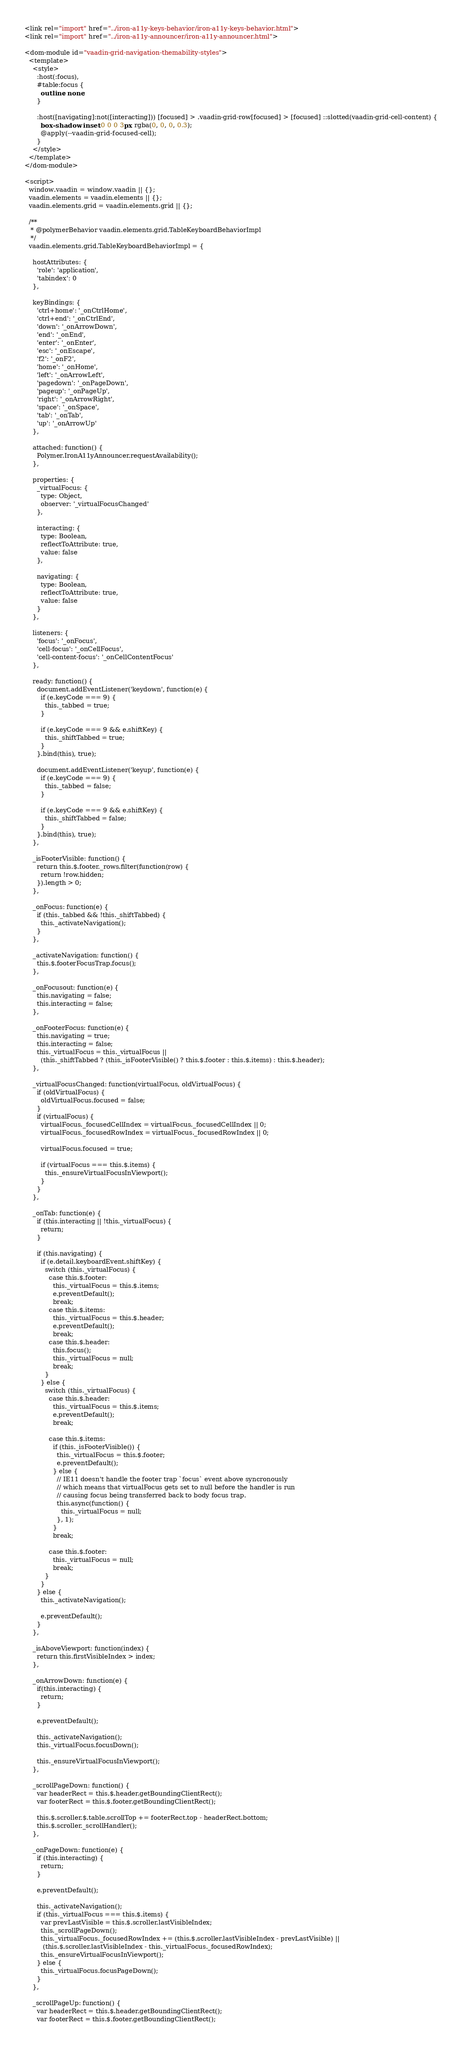<code> <loc_0><loc_0><loc_500><loc_500><_HTML_><link rel="import" href="../iron-a11y-keys-behavior/iron-a11y-keys-behavior.html">
<link rel="import" href="../iron-a11y-announcer/iron-a11y-announcer.html">

<dom-module id="vaadin-grid-navigation-themability-styles">
  <template>
    <style>
      :host(:focus),
      #table:focus {
        outline: none;
      }

      :host([navigating]:not([interacting])) [focused] > .vaadin-grid-row[focused] > [focused] ::slotted(vaadin-grid-cell-content) {
        box-shadow: inset 0 0 0 3px rgba(0, 0, 0, 0.3);
        @apply(--vaadin-grid-focused-cell);
      }
    </style>
  </template>
</dom-module>

<script>
  window.vaadin = window.vaadin || {};
  vaadin.elements = vaadin.elements || {};
  vaadin.elements.grid = vaadin.elements.grid || {};

  /**
   * @polymerBehavior vaadin.elements.grid.TableKeyboardBehaviorImpl
   */
  vaadin.elements.grid.TableKeyboardBehaviorImpl = {

    hostAttributes: {
      'role': 'application',
      'tabindex': 0
    },

    keyBindings: {
      'ctrl+home': '_onCtrlHome',
      'ctrl+end': '_onCtrlEnd',
      'down': '_onArrowDown',
      'end': '_onEnd',
      'enter': '_onEnter',
      'esc': '_onEscape',
      'f2': '_onF2',
      'home': '_onHome',
      'left': '_onArrowLeft',
      'pagedown': '_onPageDown',
      'pageup': '_onPageUp',
      'right': '_onArrowRight',
      'space': '_onSpace',
      'tab': '_onTab',
      'up': '_onArrowUp'
    },

    attached: function() {
      Polymer.IronA11yAnnouncer.requestAvailability();
    },

    properties: {
      _virtualFocus: {
        type: Object,
        observer: '_virtualFocusChanged'
      },

      interacting: {
        type: Boolean,
        reflectToAttribute: true,
        value: false
      },

      navigating: {
        type: Boolean,
        reflectToAttribute: true,
        value: false
      }
    },

    listeners: {
      'focus': '_onFocus',
      'cell-focus': '_onCellFocus',
      'cell-content-focus': '_onCellContentFocus'
    },

    ready: function() {
      document.addEventListener('keydown', function(e) {
        if (e.keyCode === 9) {
          this._tabbed = true;
        }

        if (e.keyCode === 9 && e.shiftKey) {
          this._shiftTabbed = true;
        }
      }.bind(this), true);

      document.addEventListener('keyup', function(e) {
        if (e.keyCode === 9) {
          this._tabbed = false;
        }

        if (e.keyCode === 9 && e.shiftKey) {
          this._shiftTabbed = false;
        }
      }.bind(this), true);
    },

    _isFooterVisible: function() {
      return this.$.footer._rows.filter(function(row) {
        return !row.hidden;
      }).length > 0;
    },

    _onFocus: function(e) {
      if (this._tabbed && !this._shiftTabbed) {
        this._activateNavigation();
      }
    },

    _activateNavigation: function() {
      this.$.footerFocusTrap.focus();
    },

    _onFocusout: function(e) {
      this.navigating = false;
      this.interacting = false;
    },

    _onFooterFocus: function(e) {
      this.navigating = true;
      this.interacting = false;
      this._virtualFocus = this._virtualFocus ||
        (this._shiftTabbed ? (this._isFooterVisible() ? this.$.footer : this.$.items) : this.$.header);
    },

    _virtualFocusChanged: function(virtualFocus, oldVirtualFocus) {
      if (oldVirtualFocus) {
        oldVirtualFocus.focused = false;
      }
      if (virtualFocus) {
        virtualFocus._focusedCellIndex = virtualFocus._focusedCellIndex || 0;
        virtualFocus._focusedRowIndex = virtualFocus._focusedRowIndex || 0;

        virtualFocus.focused = true;

        if (virtualFocus === this.$.items) {
          this._ensureVirtualFocusInViewport();
        }
      }
    },

    _onTab: function(e) {
      if (this.interacting || !this._virtualFocus) {
        return;
      }

      if (this.navigating) {
        if (e.detail.keyboardEvent.shiftKey) {
          switch (this._virtualFocus) {
            case this.$.footer:
              this._virtualFocus = this.$.items;
              e.preventDefault();
              break;
            case this.$.items:
              this._virtualFocus = this.$.header;
              e.preventDefault();
              break;
            case this.$.header:
              this.focus();
              this._virtualFocus = null;
              break;
          }
        } else {
          switch (this._virtualFocus) {
            case this.$.header:
              this._virtualFocus = this.$.items;
              e.preventDefault();
              break;

            case this.$.items:
              if (this._isFooterVisible()) {
                this._virtualFocus = this.$.footer;
                e.preventDefault();
              } else {
                // IE11 doesn't handle the footer trap `focus` event above syncronously
                // which means that virtualFocus gets set to null before the handler is run
                // causing focus being transferred back to body focus trap.
                this.async(function() {
                  this._virtualFocus = null;
                }, 1);
              }
              break;

            case this.$.footer:
              this._virtualFocus = null;
              break;
          }
        }
      } else {
        this._activateNavigation();

        e.preventDefault();
      }
    },

    _isAboveViewport: function(index) {
      return this.firstVisibleIndex > index;
    },

    _onArrowDown: function(e) {
      if(this.interacting) {
        return;
      }

      e.preventDefault();

      this._activateNavigation();
      this._virtualFocus.focusDown();

      this._ensureVirtualFocusInViewport();
    },

    _scrollPageDown: function() {
      var headerRect = this.$.header.getBoundingClientRect();
      var footerRect = this.$.footer.getBoundingClientRect();

      this.$.scroller.$.table.scrollTop += footerRect.top - headerRect.bottom;
      this.$.scroller._scrollHandler();
    },

    _onPageDown: function(e) {
      if (this.interacting) {
        return;
      }

      e.preventDefault();

      this._activateNavigation();
      if (this._virtualFocus === this.$.items) {
        var prevLastVisible = this.$.scroller.lastVisibleIndex;
        this._scrollPageDown();
        this._virtualFocus._focusedRowIndex += (this.$.scroller.lastVisibleIndex - prevLastVisible) ||
         (this.$.scroller.lastVisibleIndex - this._virtualFocus._focusedRowIndex);
        this._ensureVirtualFocusInViewport();
      } else {
        this._virtualFocus.focusPageDown();
      }
    },

    _scrollPageUp: function() {
      var headerRect = this.$.header.getBoundingClientRect();
      var footerRect = this.$.footer.getBoundingClientRect();
</code> 